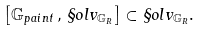<formula> <loc_0><loc_0><loc_500><loc_500>\left [ \mathbb { G } _ { p a i n t } \, , \, \S o l v _ { \mathbb { G } _ { R } } \right ] \subset \S o l v _ { \mathbb { G } _ { R } } .</formula> 